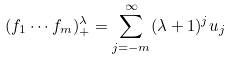<formula> <loc_0><loc_0><loc_500><loc_500>( f _ { 1 } \cdots f _ { m } ) _ { + } ^ { \lambda } = \sum _ { j = - m } ^ { \infty } ( \lambda + 1 ) ^ { j } u _ { j }</formula> 